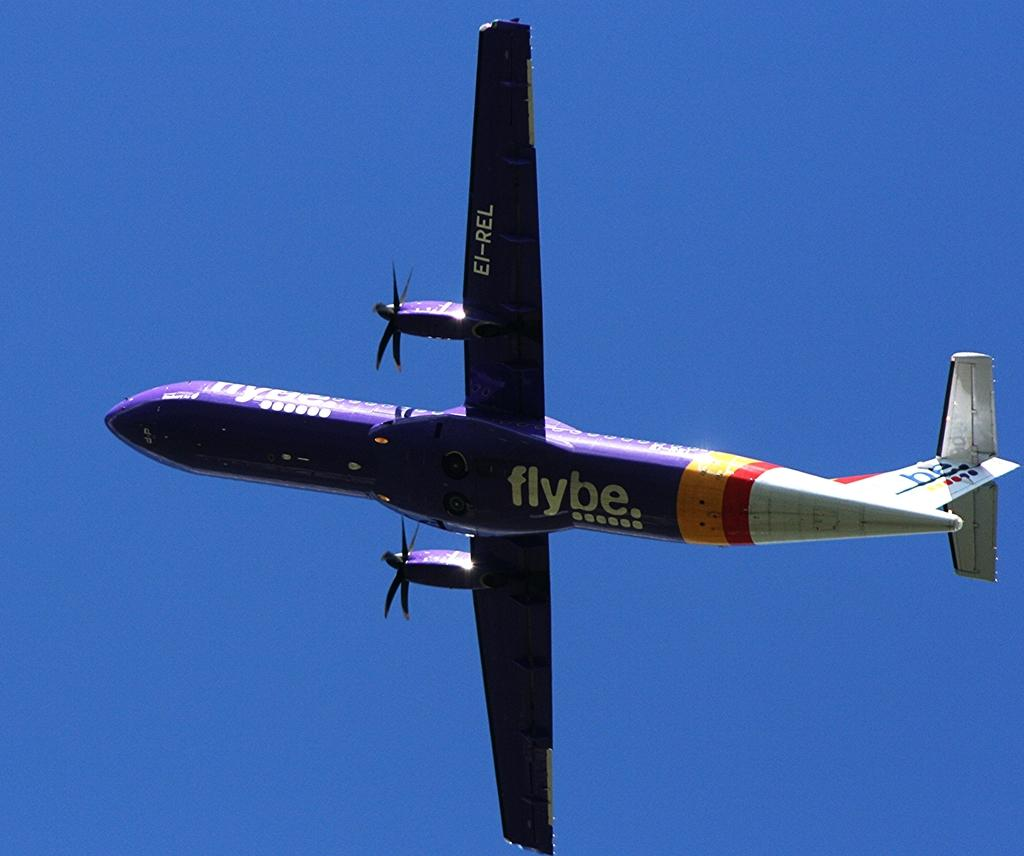What color is the background of the image? The background of the image is blue. What is the main subject in the center of the image? There is an aeroplane at the center of the image. What type of plant is growing near the aeroplane in the image? There is no plant visible in the image; it only features an aeroplane against a blue background. 